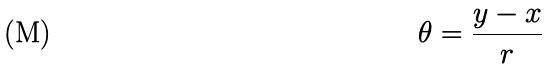Convert formula to latex. <formula><loc_0><loc_0><loc_500><loc_500>\theta = \frac { y - x } { r }</formula> 